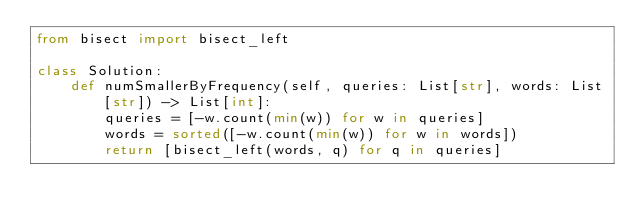Convert code to text. <code><loc_0><loc_0><loc_500><loc_500><_Python_>from bisect import bisect_left

class Solution:
    def numSmallerByFrequency(self, queries: List[str], words: List[str]) -> List[int]:  
        queries = [-w.count(min(w)) for w in queries]
        words = sorted([-w.count(min(w)) for w in words])
        return [bisect_left(words, q) for q in queries]</code> 